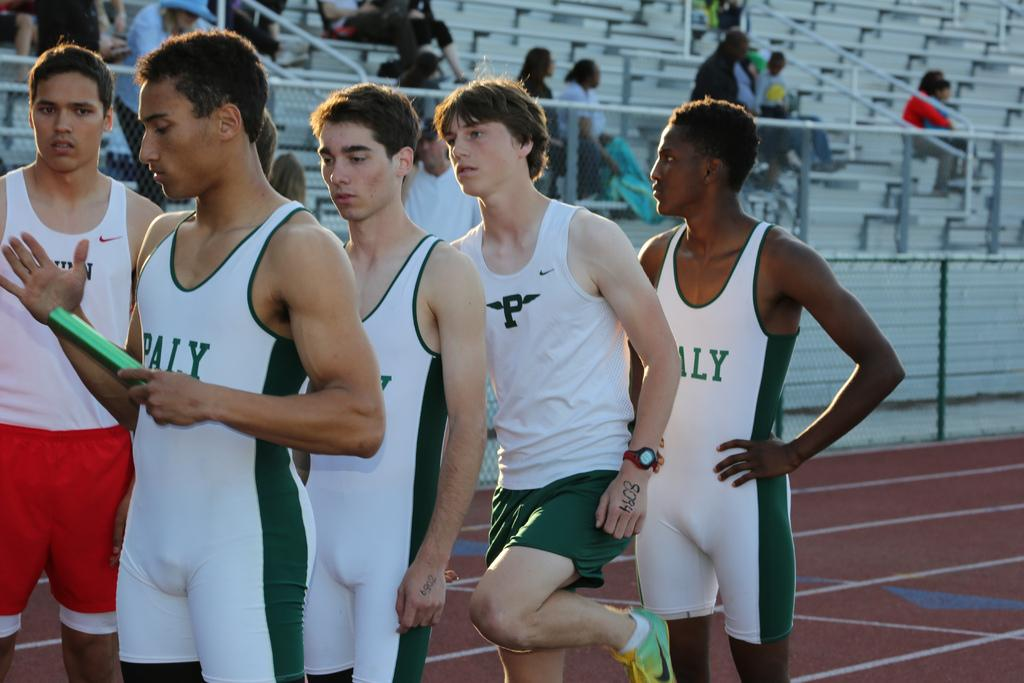<image>
Relay a brief, clear account of the picture shown. The uniforms the men have on say Paly on the front 